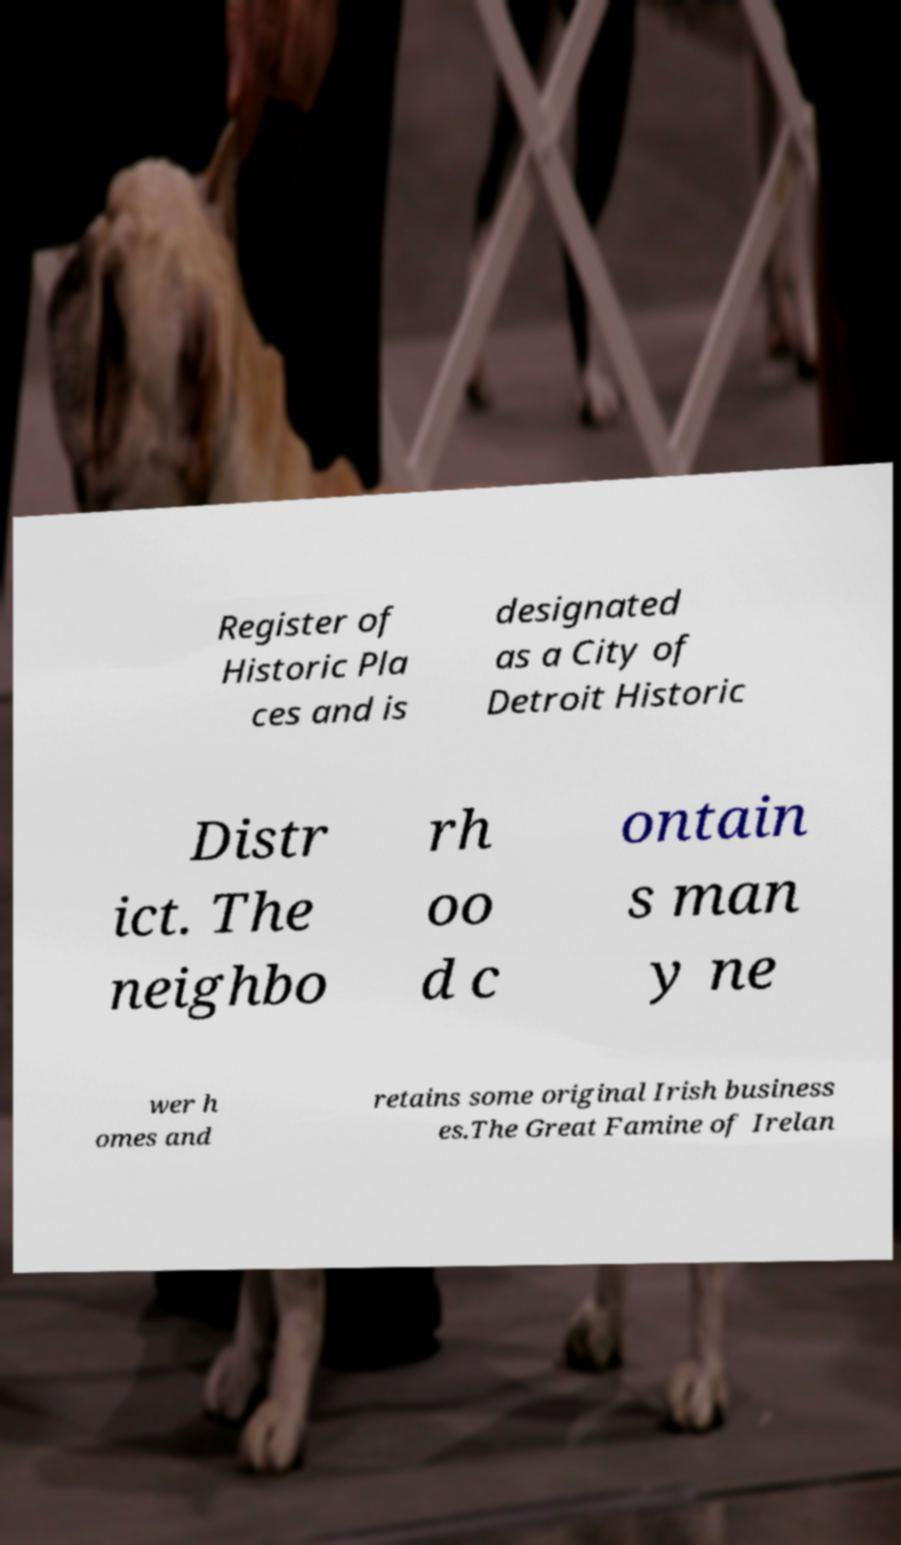Could you assist in decoding the text presented in this image and type it out clearly? Register of Historic Pla ces and is designated as a City of Detroit Historic Distr ict. The neighbo rh oo d c ontain s man y ne wer h omes and retains some original Irish business es.The Great Famine of Irelan 